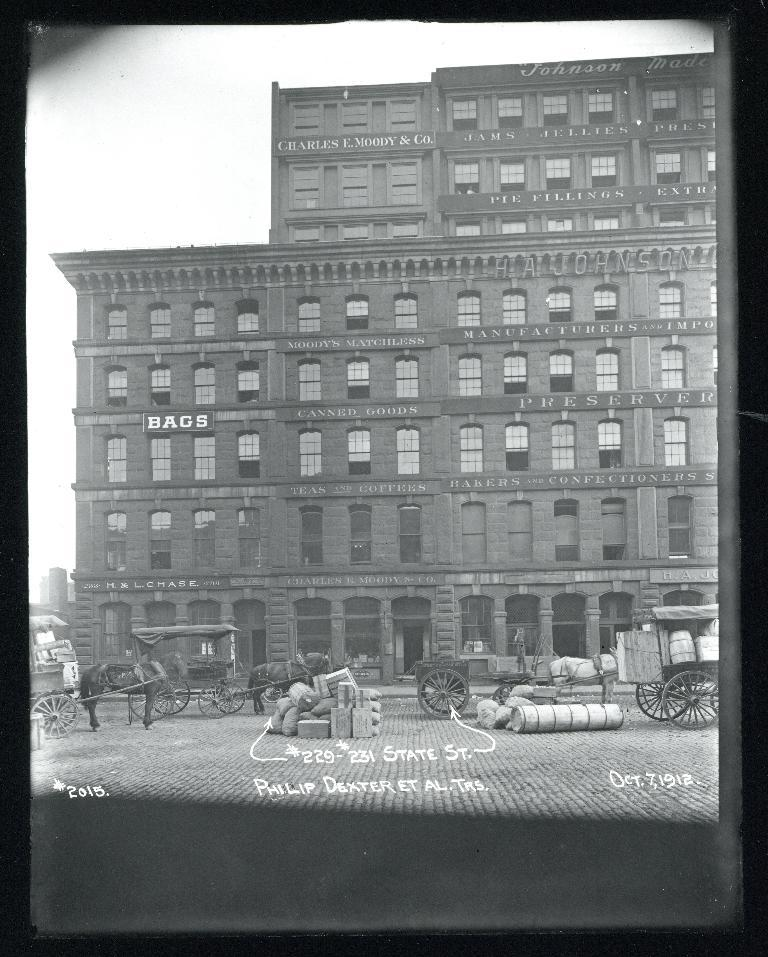What is the color scheme of the image? The image is black and white. What is the main structure in the image? There is a big building in the image. What mode of transportation is present in front of the building? There is a horse cart in front of the building. What might be associated with travel or transport in the image? There is luggage near the horse cart. What hobbies does the brother of the person who took the photo have? There is no information about a brother or their hobbies in the image or the provided facts. 